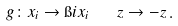Convert formula to latex. <formula><loc_0><loc_0><loc_500><loc_500>g \colon x _ { i } \to \i i x _ { i } \quad z \to - z \, .</formula> 